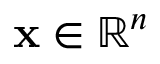<formula> <loc_0><loc_0><loc_500><loc_500>x \in \mathbb { R } ^ { n }</formula> 